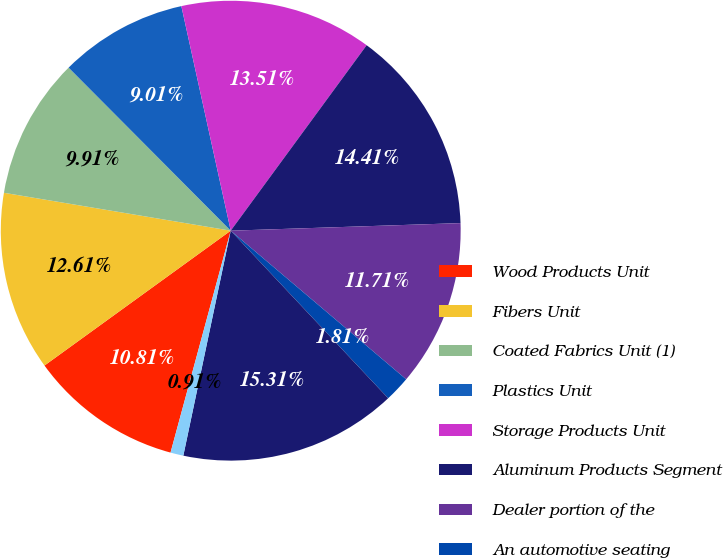Convert chart. <chart><loc_0><loc_0><loc_500><loc_500><pie_chart><fcel>Wood Products Unit<fcel>Fibers Unit<fcel>Coated Fabrics Unit (1)<fcel>Plastics Unit<fcel>Storage Products Unit<fcel>Aluminum Products Segment<fcel>Dealer portion of the<fcel>An automotive seating<fcel>External sales<fcel>Prime Foam Products Unit<nl><fcel>10.81%<fcel>12.61%<fcel>9.91%<fcel>9.01%<fcel>13.51%<fcel>14.41%<fcel>11.71%<fcel>1.81%<fcel>15.31%<fcel>0.91%<nl></chart> 